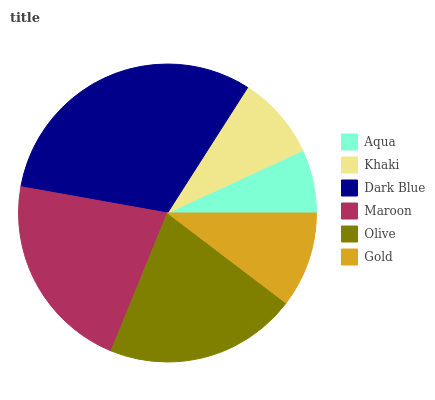Is Aqua the minimum?
Answer yes or no. Yes. Is Dark Blue the maximum?
Answer yes or no. Yes. Is Khaki the minimum?
Answer yes or no. No. Is Khaki the maximum?
Answer yes or no. No. Is Khaki greater than Aqua?
Answer yes or no. Yes. Is Aqua less than Khaki?
Answer yes or no. Yes. Is Aqua greater than Khaki?
Answer yes or no. No. Is Khaki less than Aqua?
Answer yes or no. No. Is Olive the high median?
Answer yes or no. Yes. Is Gold the low median?
Answer yes or no. Yes. Is Gold the high median?
Answer yes or no. No. Is Khaki the low median?
Answer yes or no. No. 